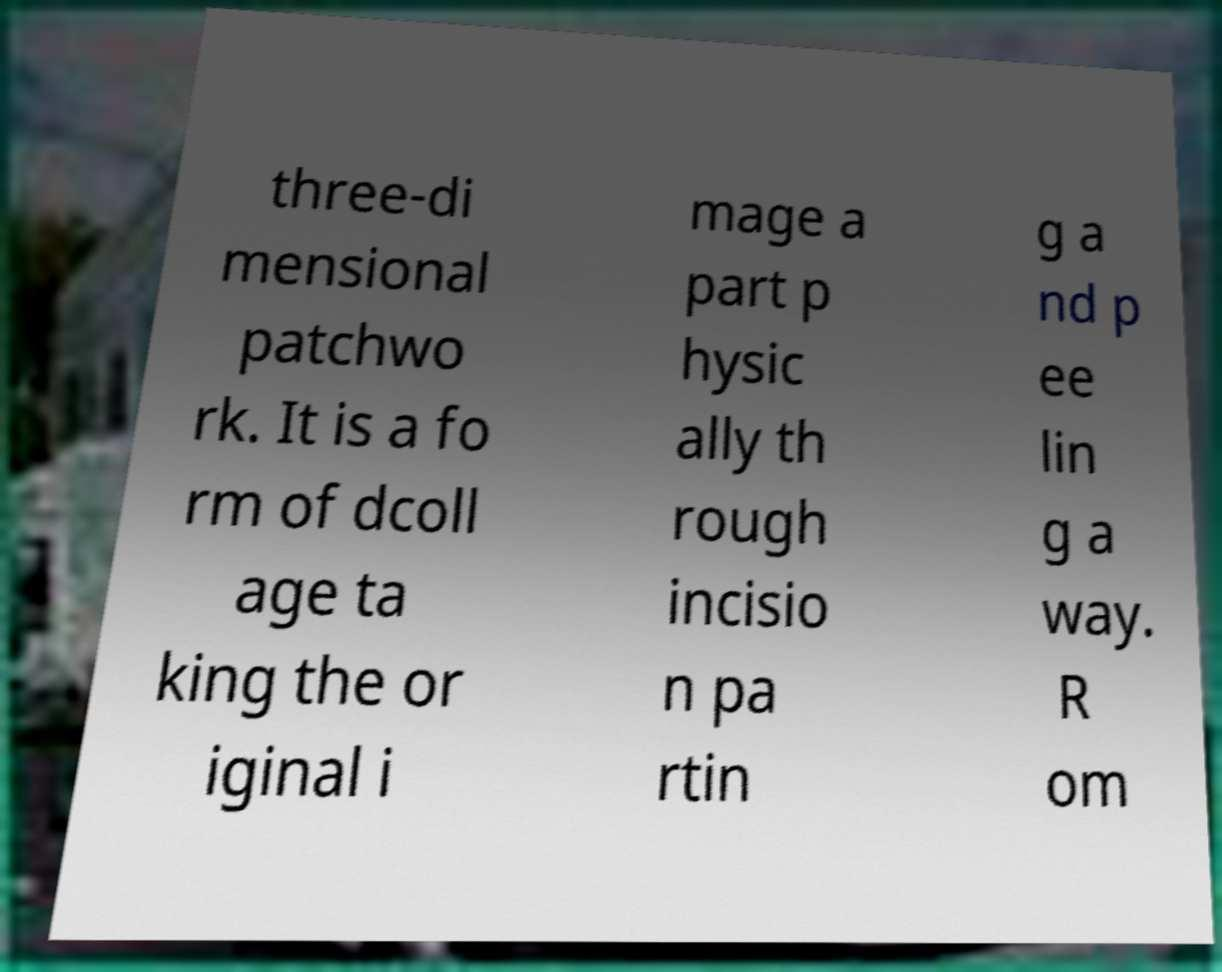Could you extract and type out the text from this image? three-di mensional patchwo rk. It is a fo rm of dcoll age ta king the or iginal i mage a part p hysic ally th rough incisio n pa rtin g a nd p ee lin g a way. R om 